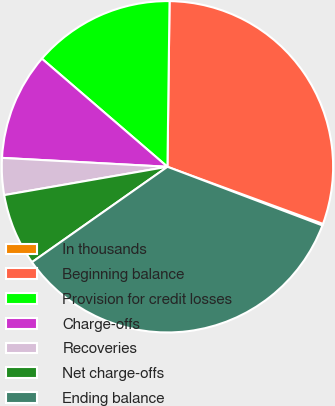<chart> <loc_0><loc_0><loc_500><loc_500><pie_chart><fcel>In thousands<fcel>Beginning balance<fcel>Provision for credit losses<fcel>Charge-offs<fcel>Recoveries<fcel>Net charge-offs<fcel>Ending balance<nl><fcel>0.16%<fcel>30.4%<fcel>13.89%<fcel>10.46%<fcel>3.59%<fcel>7.03%<fcel>34.48%<nl></chart> 